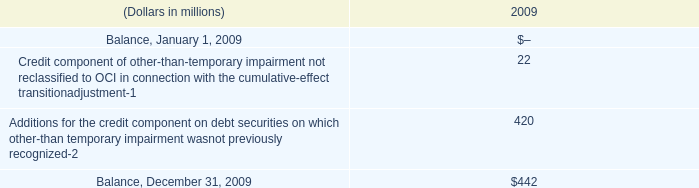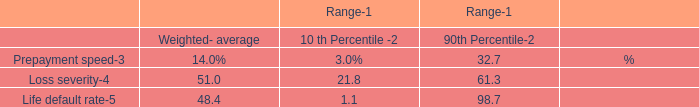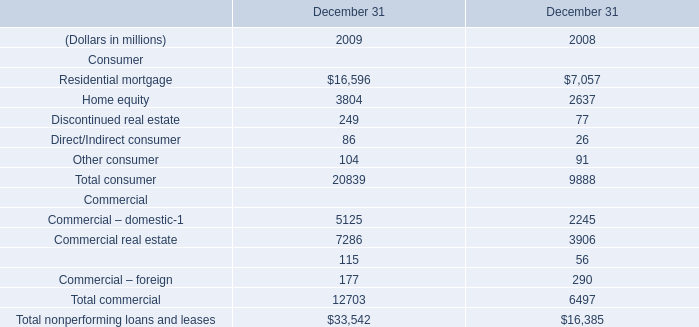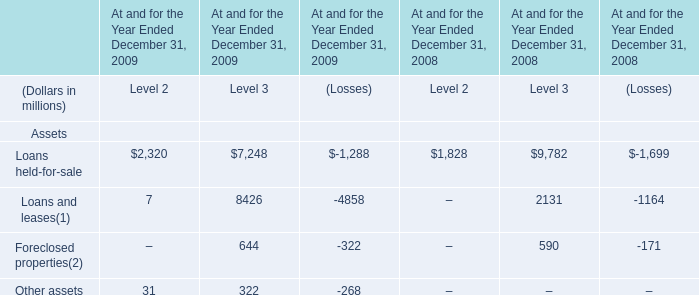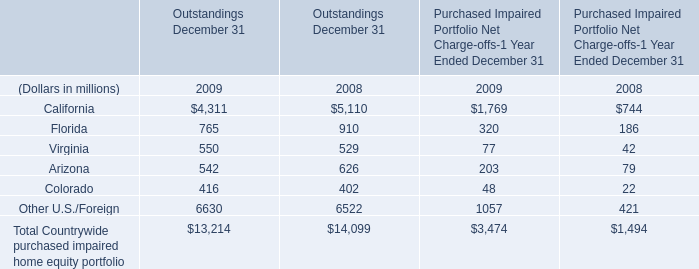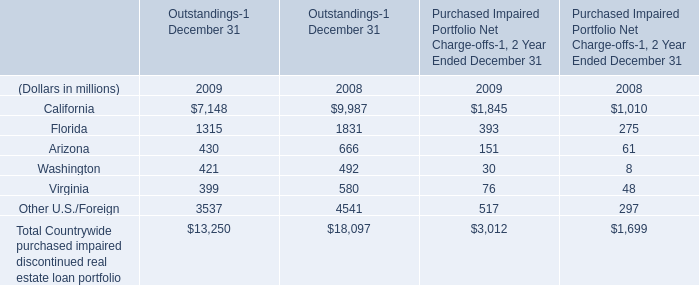what's the total amount of Other U.S./Foreign of data 1 2008, and Commercial – domestic Commercial of December 31 2008 ? 
Computations: (4541.0 + 2245.0)
Answer: 6786.0. 